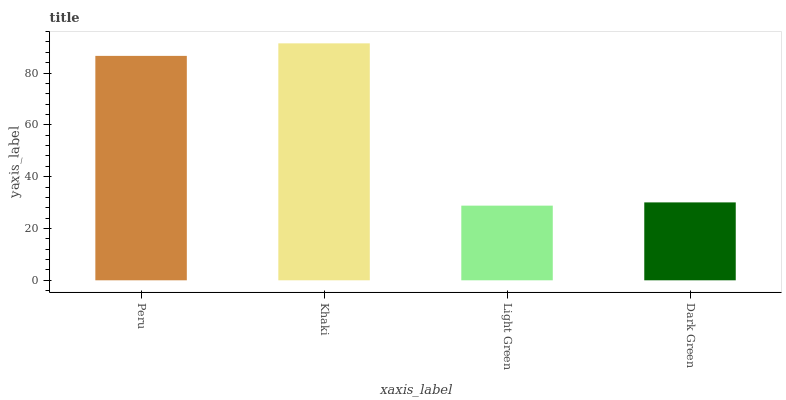Is Khaki the minimum?
Answer yes or no. No. Is Light Green the maximum?
Answer yes or no. No. Is Khaki greater than Light Green?
Answer yes or no. Yes. Is Light Green less than Khaki?
Answer yes or no. Yes. Is Light Green greater than Khaki?
Answer yes or no. No. Is Khaki less than Light Green?
Answer yes or no. No. Is Peru the high median?
Answer yes or no. Yes. Is Dark Green the low median?
Answer yes or no. Yes. Is Light Green the high median?
Answer yes or no. No. Is Light Green the low median?
Answer yes or no. No. 